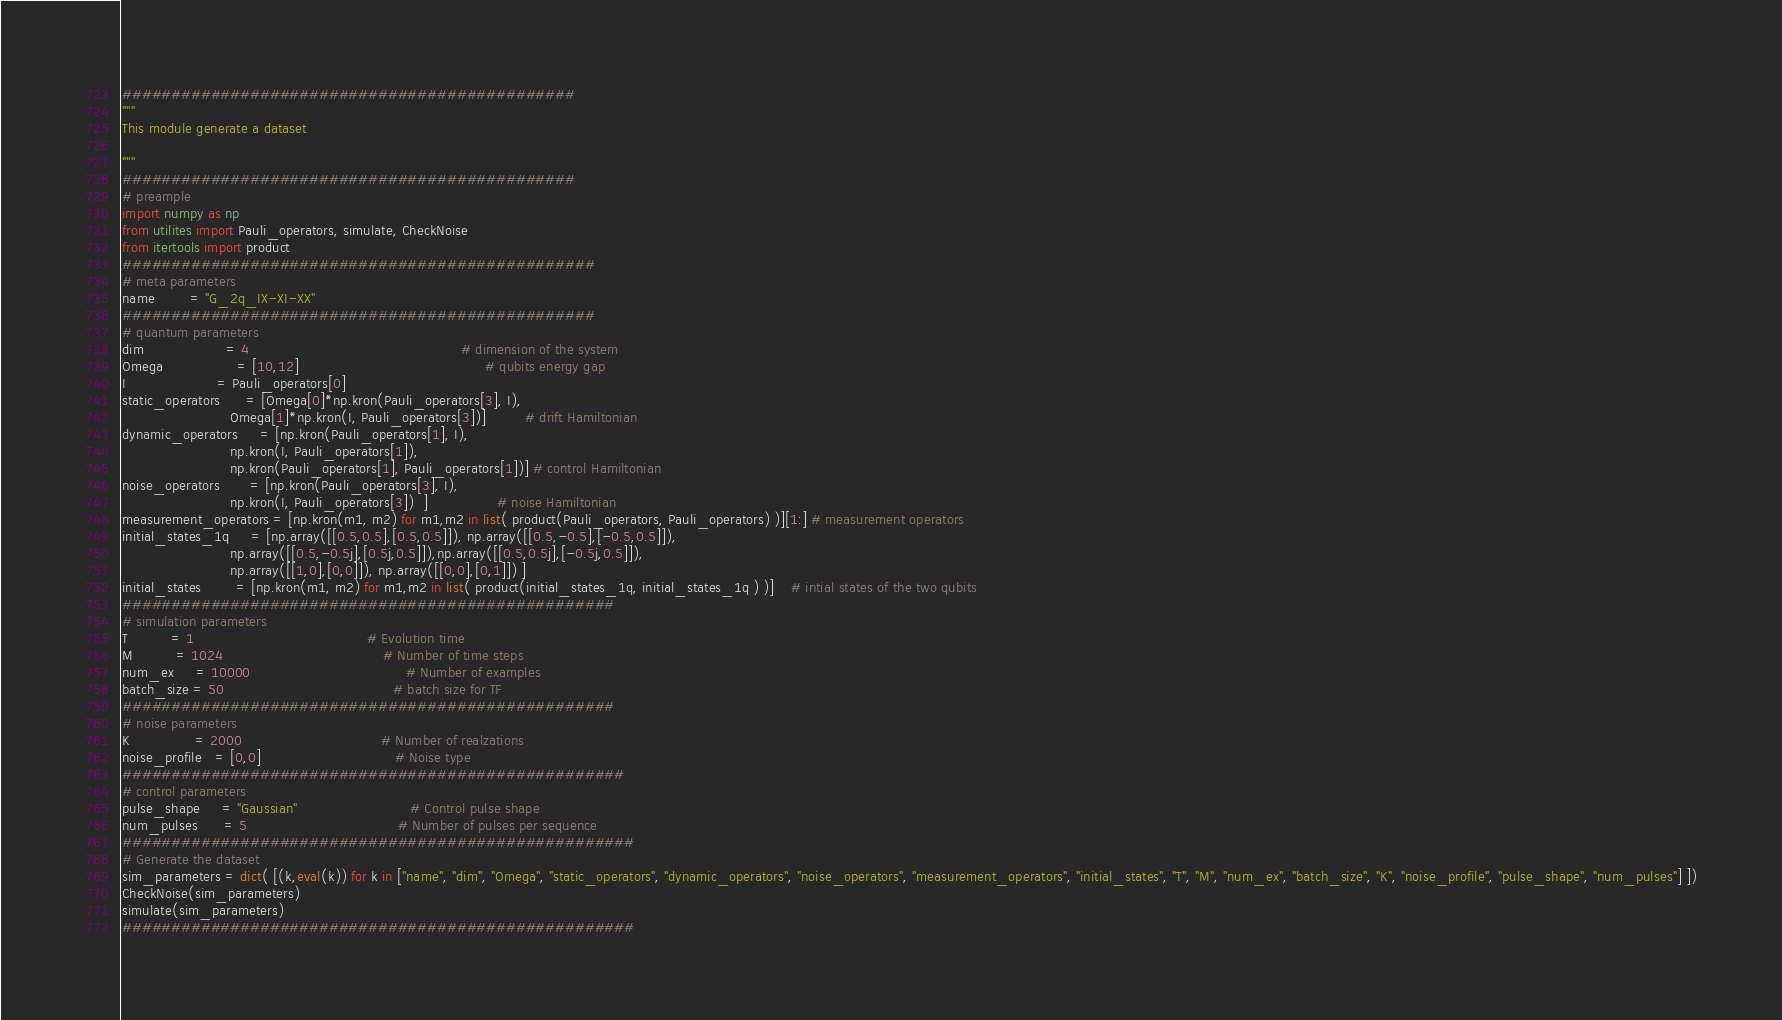Convert code to text. <code><loc_0><loc_0><loc_500><loc_500><_Python_>##############################################
"""
This module generate a dataset

"""
##############################################
# preample
import numpy as np
from utilites import Pauli_operators, simulate, CheckNoise
from itertools import product
################################################
# meta parameters
name        = "G_2q_IX-XI-XX"
################################################
# quantum parameters
dim                   = 4                                                 # dimension of the system
Omega                 = [10,12]                                           # qubits energy gap
I                     = Pauli_operators[0]
static_operators      = [Omega[0]*np.kron(Pauli_operators[3], I), 
                         Omega[1]*np.kron(I, Pauli_operators[3])]         # drift Hamiltonian
dynamic_operators     = [np.kron(Pauli_operators[1], I), 
                         np.kron(I, Pauli_operators[1]), 
                         np.kron(Pauli_operators[1], Pauli_operators[1])] # control Hamiltonian 
noise_operators       = [np.kron(Pauli_operators[3], I), 
                         np.kron(I, Pauli_operators[3])  ]                # noise Hamiltonian
measurement_operators = [np.kron(m1, m2) for m1,m2 in list( product(Pauli_operators, Pauli_operators) )][1:] # measurement operators
initial_states_1q     = [np.array([[0.5,0.5],[0.5,0.5]]), np.array([[0.5,-0.5],[-0.5,0.5]]),
                         np.array([[0.5,-0.5j],[0.5j,0.5]]),np.array([[0.5,0.5j],[-0.5j,0.5]]),
                         np.array([[1,0],[0,0]]), np.array([[0,0],[0,1]]) ]
initial_states        = [np.kron(m1, m2) for m1,m2 in list( product(initial_states_1q, initial_states_1q ) )]    # intial states of the two qubits 
##################################################                          
# simulation parameters
T          = 1                                        # Evolution time
M          = 1024                                     # Number of time steps  
num_ex     = 10000                                    # Number of examples
batch_size = 50                                       # batch size for TF 
##################################################
# noise parameters
K               = 2000                                # Number of realzations
noise_profile   = [0,0]                               # Noise type
###################################################
# control parameters
pulse_shape     = "Gaussian"                          # Control pulse shape
num_pulses      = 5                                   # Number of pulses per sequence
####################################################
# Generate the dataset
sim_parameters = dict( [(k,eval(k)) for k in ["name", "dim", "Omega", "static_operators", "dynamic_operators", "noise_operators", "measurement_operators", "initial_states", "T", "M", "num_ex", "batch_size", "K", "noise_profile", "pulse_shape", "num_pulses"] ])
CheckNoise(sim_parameters)
simulate(sim_parameters)
####################################################</code> 